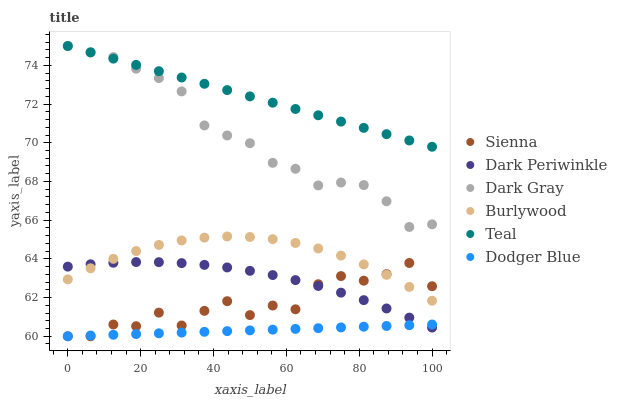Does Dodger Blue have the minimum area under the curve?
Answer yes or no. Yes. Does Teal have the maximum area under the curve?
Answer yes or no. Yes. Does Burlywood have the minimum area under the curve?
Answer yes or no. No. Does Burlywood have the maximum area under the curve?
Answer yes or no. No. Is Dodger Blue the smoothest?
Answer yes or no. Yes. Is Sienna the roughest?
Answer yes or no. Yes. Is Burlywood the smoothest?
Answer yes or no. No. Is Burlywood the roughest?
Answer yes or no. No. Does Sienna have the lowest value?
Answer yes or no. Yes. Does Burlywood have the lowest value?
Answer yes or no. No. Does Teal have the highest value?
Answer yes or no. Yes. Does Burlywood have the highest value?
Answer yes or no. No. Is Dodger Blue less than Burlywood?
Answer yes or no. Yes. Is Teal greater than Burlywood?
Answer yes or no. Yes. Does Dark Gray intersect Teal?
Answer yes or no. Yes. Is Dark Gray less than Teal?
Answer yes or no. No. Is Dark Gray greater than Teal?
Answer yes or no. No. Does Dodger Blue intersect Burlywood?
Answer yes or no. No. 